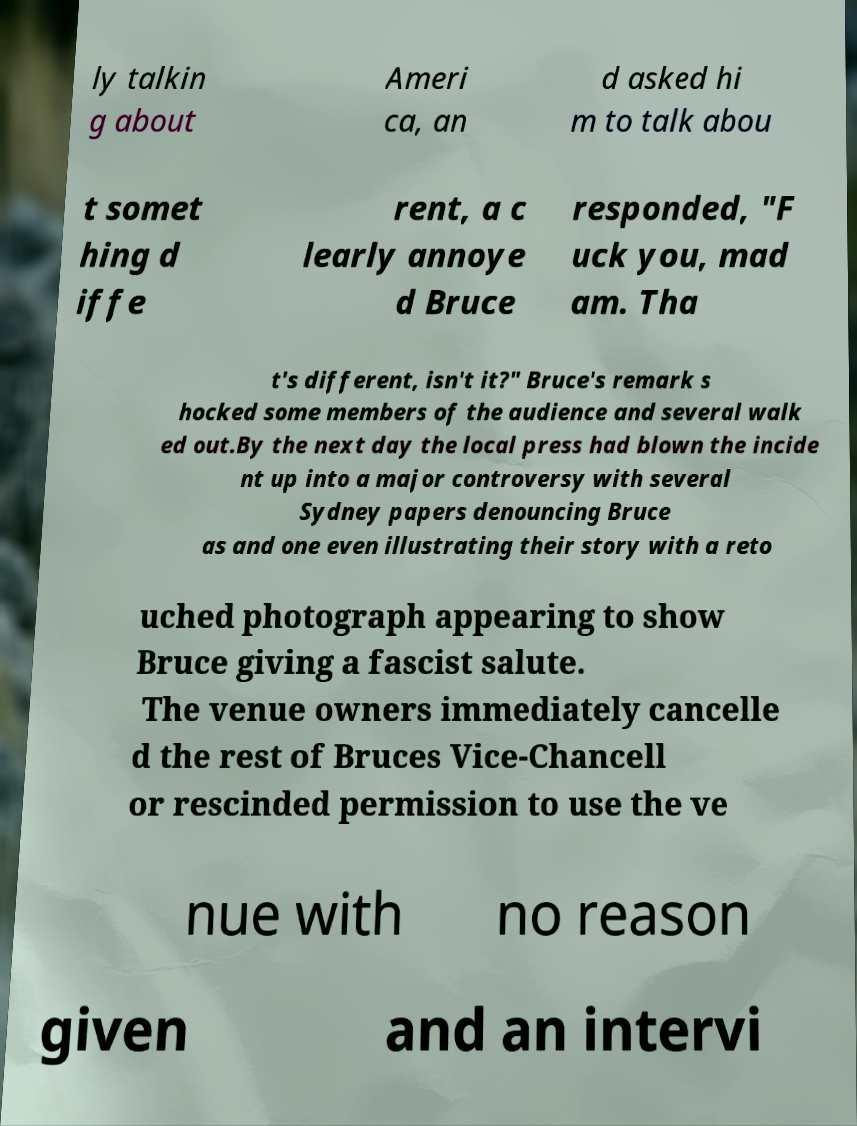Could you assist in decoding the text presented in this image and type it out clearly? ly talkin g about Ameri ca, an d asked hi m to talk abou t somet hing d iffe rent, a c learly annoye d Bruce responded, "F uck you, mad am. Tha t's different, isn't it?" Bruce's remark s hocked some members of the audience and several walk ed out.By the next day the local press had blown the incide nt up into a major controversy with several Sydney papers denouncing Bruce as and one even illustrating their story with a reto uched photograph appearing to show Bruce giving a fascist salute. The venue owners immediately cancelle d the rest of Bruces Vice-Chancell or rescinded permission to use the ve nue with no reason given and an intervi 